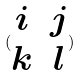Convert formula to latex. <formula><loc_0><loc_0><loc_500><loc_500>( \begin{matrix} i & j \\ k & l \end{matrix} )</formula> 